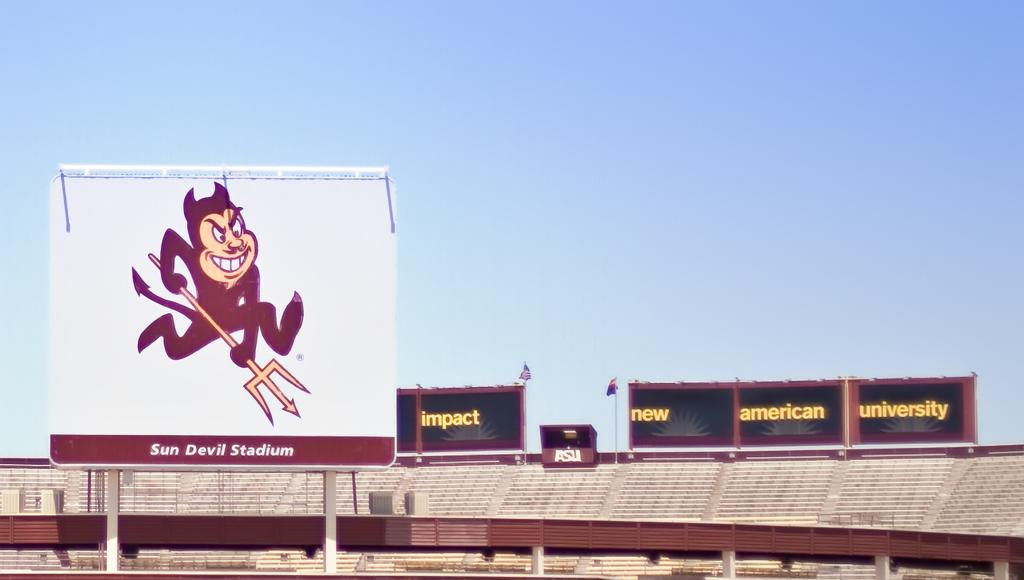<image>
Share a concise interpretation of the image provided. A Satan cartoon depicts Sun Devil Stadium, which is empty. 